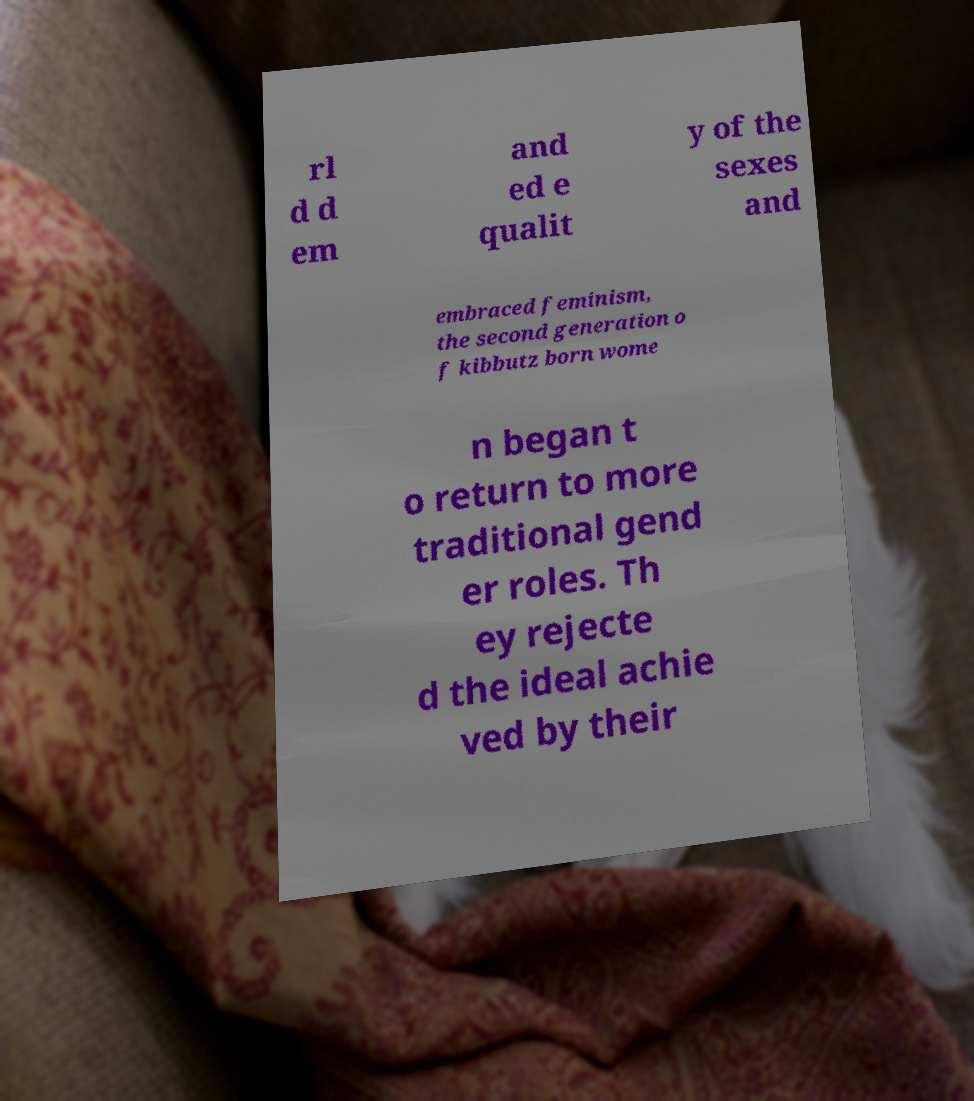There's text embedded in this image that I need extracted. Can you transcribe it verbatim? rl d d em and ed e qualit y of the sexes and embraced feminism, the second generation o f kibbutz born wome n began t o return to more traditional gend er roles. Th ey rejecte d the ideal achie ved by their 